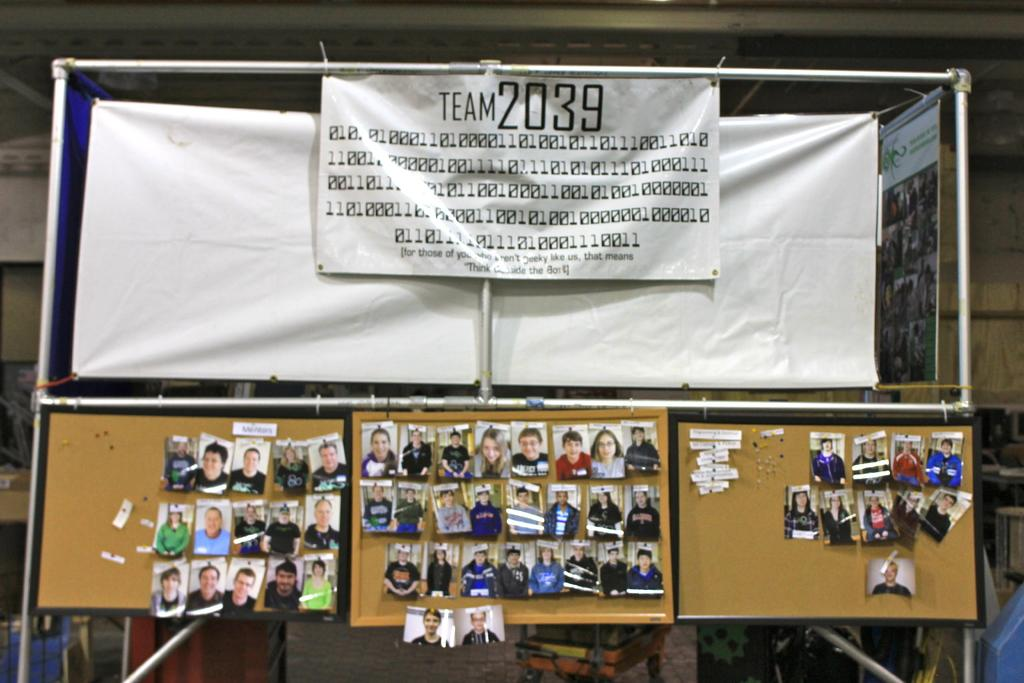<image>
Summarize the visual content of the image. Three cork boards hang from a metal post under a banner reading Team 2039. 